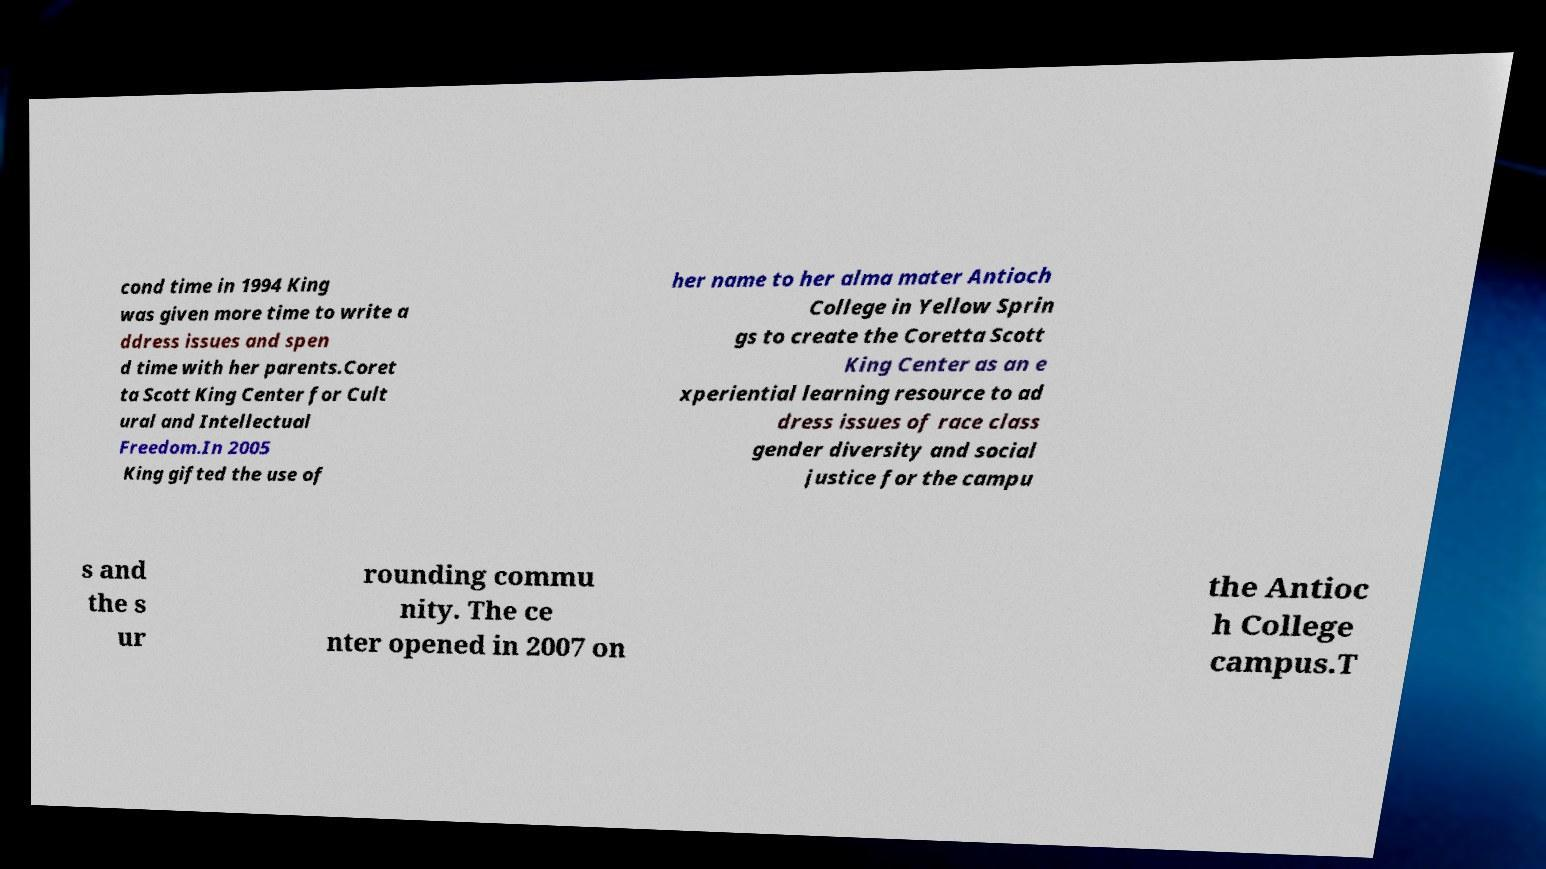Please identify and transcribe the text found in this image. cond time in 1994 King was given more time to write a ddress issues and spen d time with her parents.Coret ta Scott King Center for Cult ural and Intellectual Freedom.In 2005 King gifted the use of her name to her alma mater Antioch College in Yellow Sprin gs to create the Coretta Scott King Center as an e xperiential learning resource to ad dress issues of race class gender diversity and social justice for the campu s and the s ur rounding commu nity. The ce nter opened in 2007 on the Antioc h College campus.T 